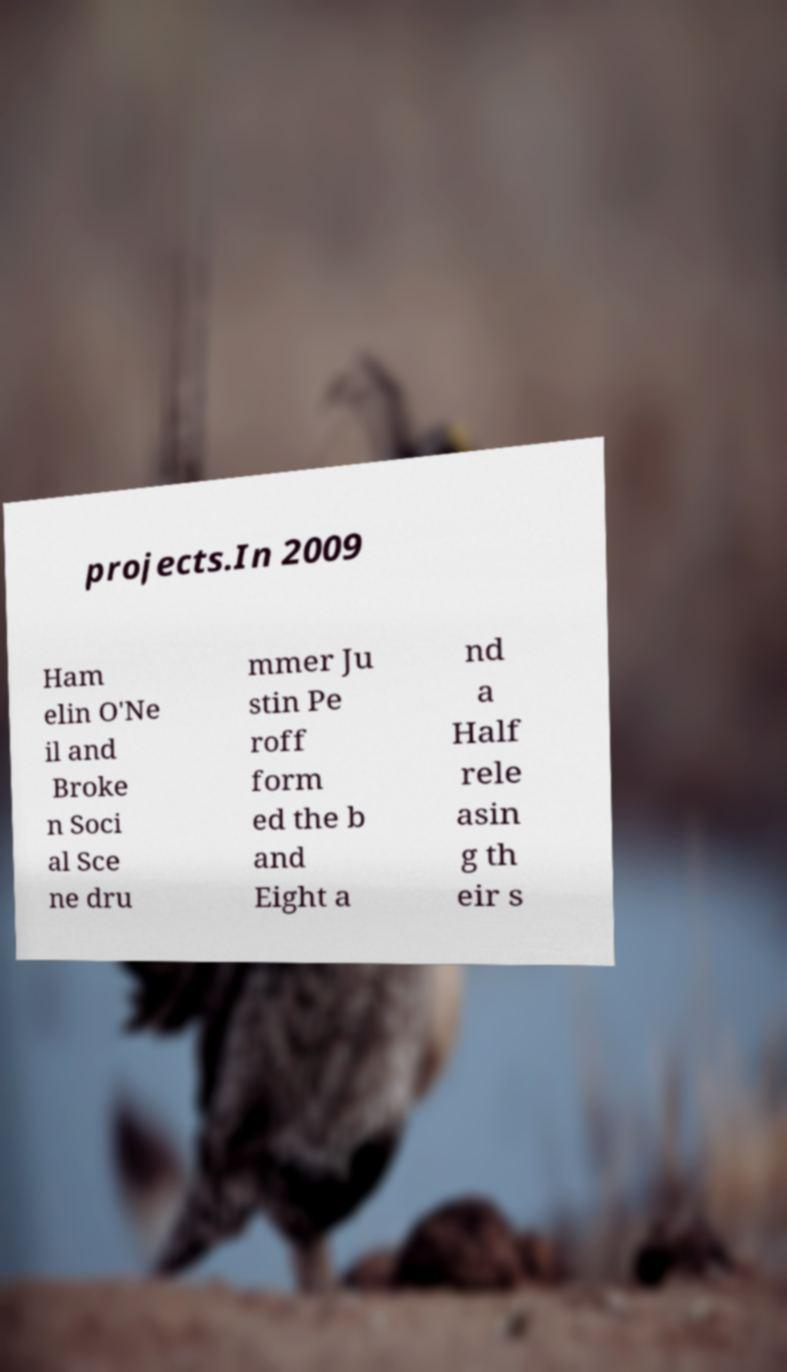For documentation purposes, I need the text within this image transcribed. Could you provide that? projects.In 2009 Ham elin O'Ne il and Broke n Soci al Sce ne dru mmer Ju stin Pe roff form ed the b and Eight a nd a Half rele asin g th eir s 